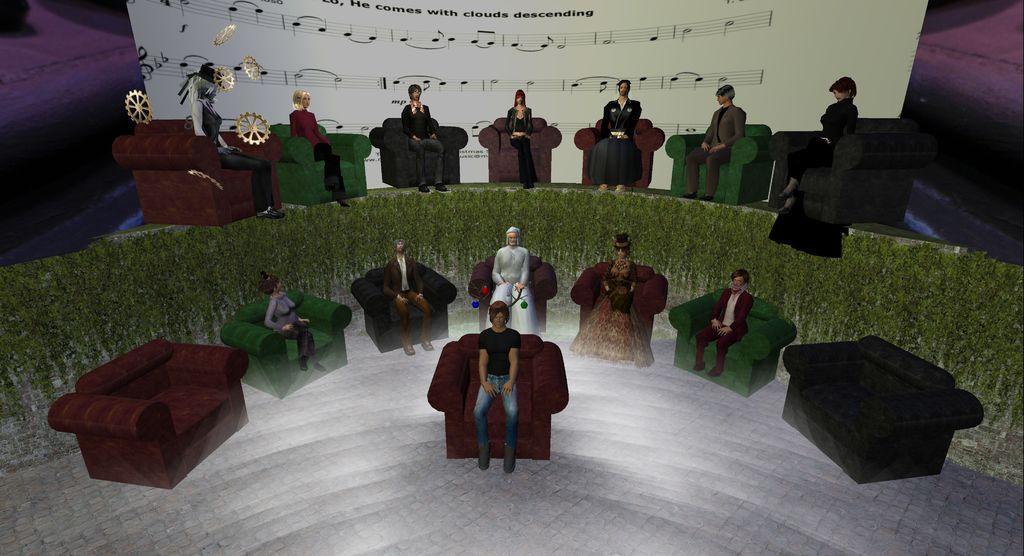In one or two sentences, can you explain what this image depicts? This is an animated image. In this image there are a few people sitting on the individual couch. In the background there is a board with some images and text on it. 